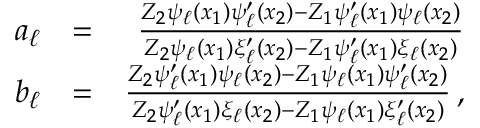<formula> <loc_0><loc_0><loc_500><loc_500>\begin{array} { r l r } { a _ { \ell } } & { = } & { \frac { Z _ { 2 } \psi _ { \ell } ( x _ { 1 } ) \psi _ { \ell } ^ { \prime } ( x _ { 2 } ) - Z _ { 1 } \psi _ { \ell } ^ { \prime } ( x _ { 1 } ) \psi _ { \ell } ( x _ { 2 } ) } { Z _ { 2 } \psi _ { \ell } ( x _ { 1 } ) \xi _ { \ell } ^ { \prime } ( x _ { 2 } ) - Z _ { 1 } \psi _ { \ell } ^ { \prime } ( x _ { 1 } ) \xi _ { \ell } ( x _ { 2 } ) } } \\ { b _ { \ell } } & { = } & { \frac { Z _ { 2 } \psi _ { \ell } ^ { \prime } ( x _ { 1 } ) \psi _ { \ell } ( x _ { 2 } ) - Z _ { 1 } \psi _ { \ell } ( x _ { 1 } ) \psi _ { \ell } ^ { \prime } ( x _ { 2 } ) } { Z _ { 2 } \psi _ { \ell } ^ { \prime } ( x _ { 1 } ) \xi _ { \ell } ( x _ { 2 } ) - Z _ { 1 } \psi _ { \ell } ( x _ { 1 } ) \xi _ { \ell } ^ { \prime } ( x _ { 2 } ) } \, , } \end{array}</formula> 